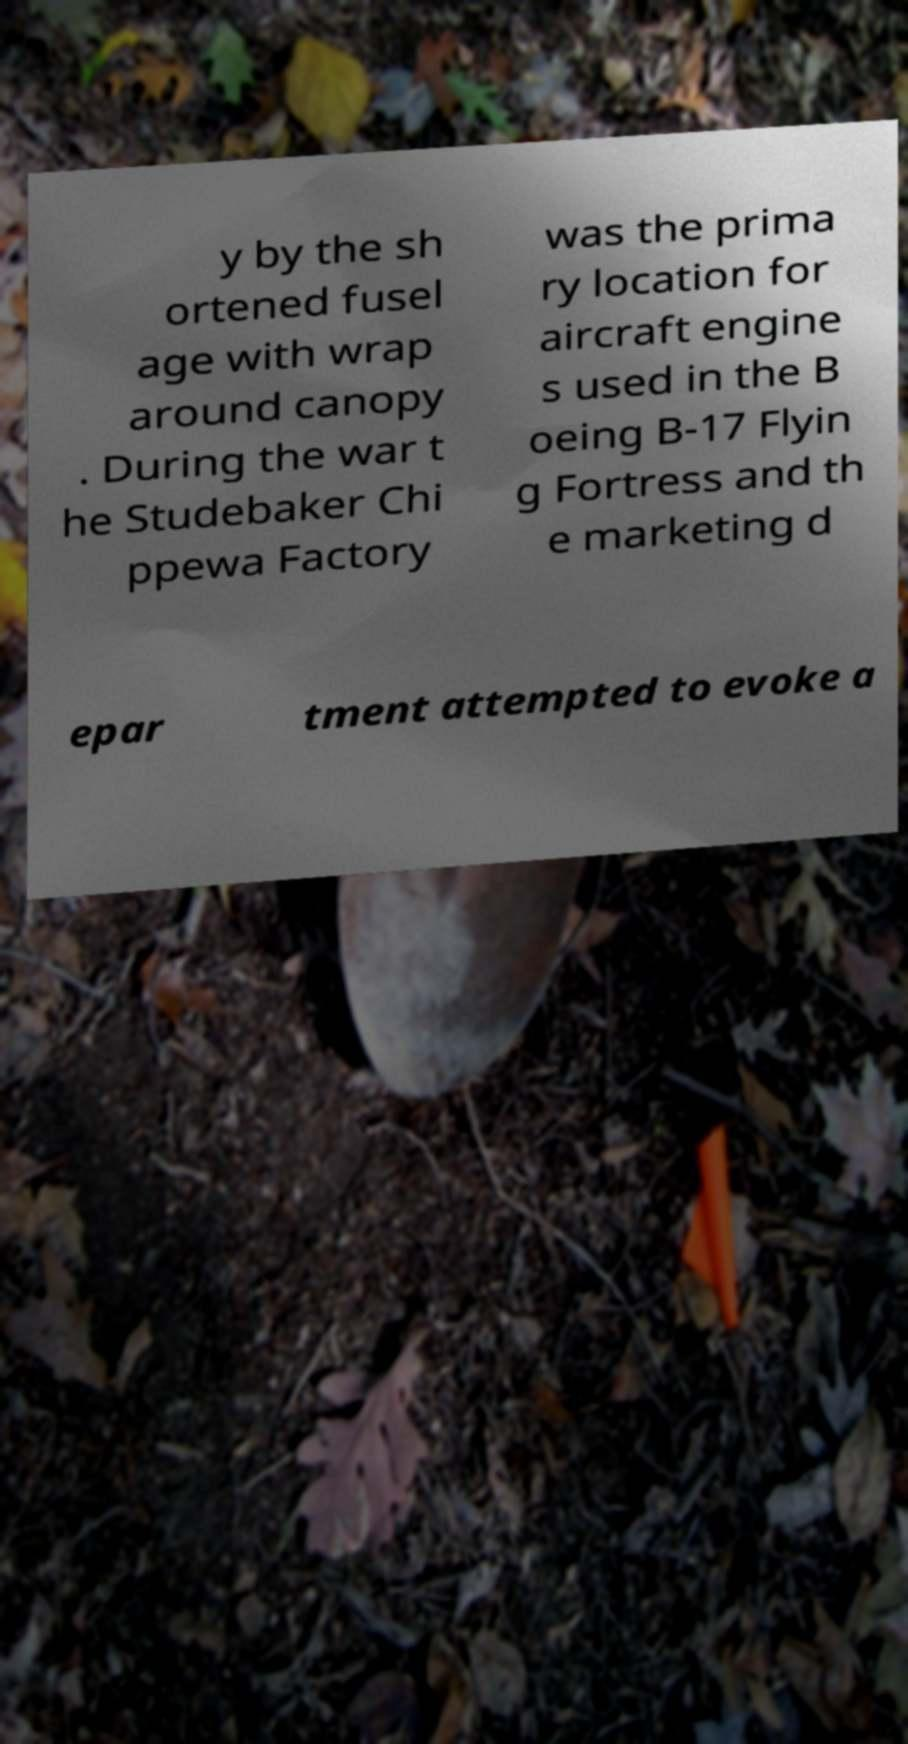There's text embedded in this image that I need extracted. Can you transcribe it verbatim? y by the sh ortened fusel age with wrap around canopy . During the war t he Studebaker Chi ppewa Factory was the prima ry location for aircraft engine s used in the B oeing B-17 Flyin g Fortress and th e marketing d epar tment attempted to evoke a 